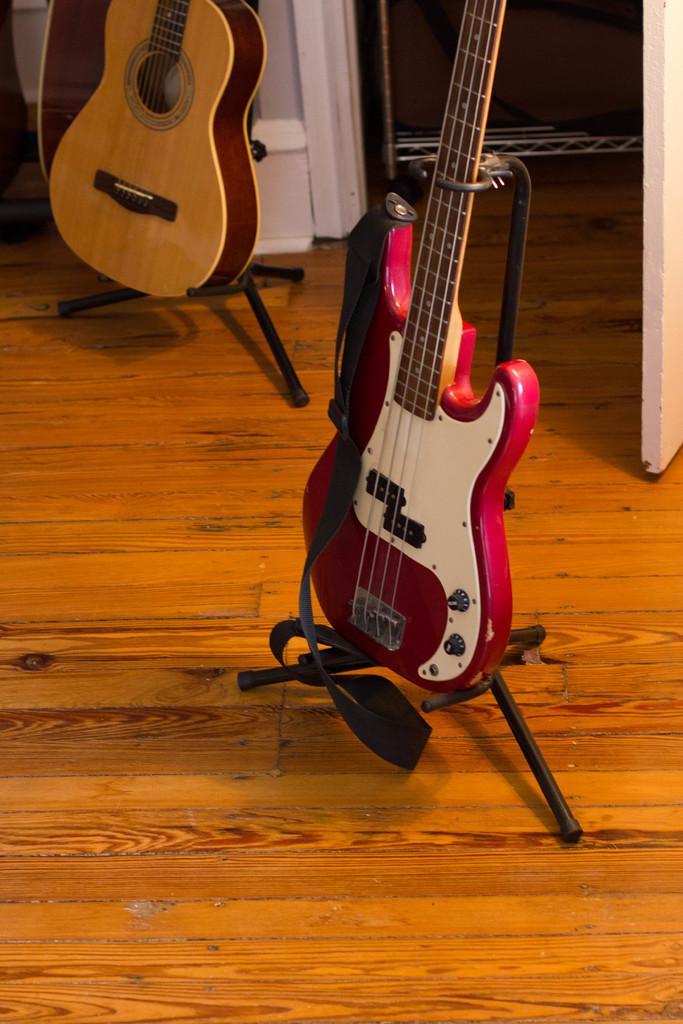Could you give a brief overview of what you see in this image? The image consists of two guitar which are kept in the stand, which is on the floor. 